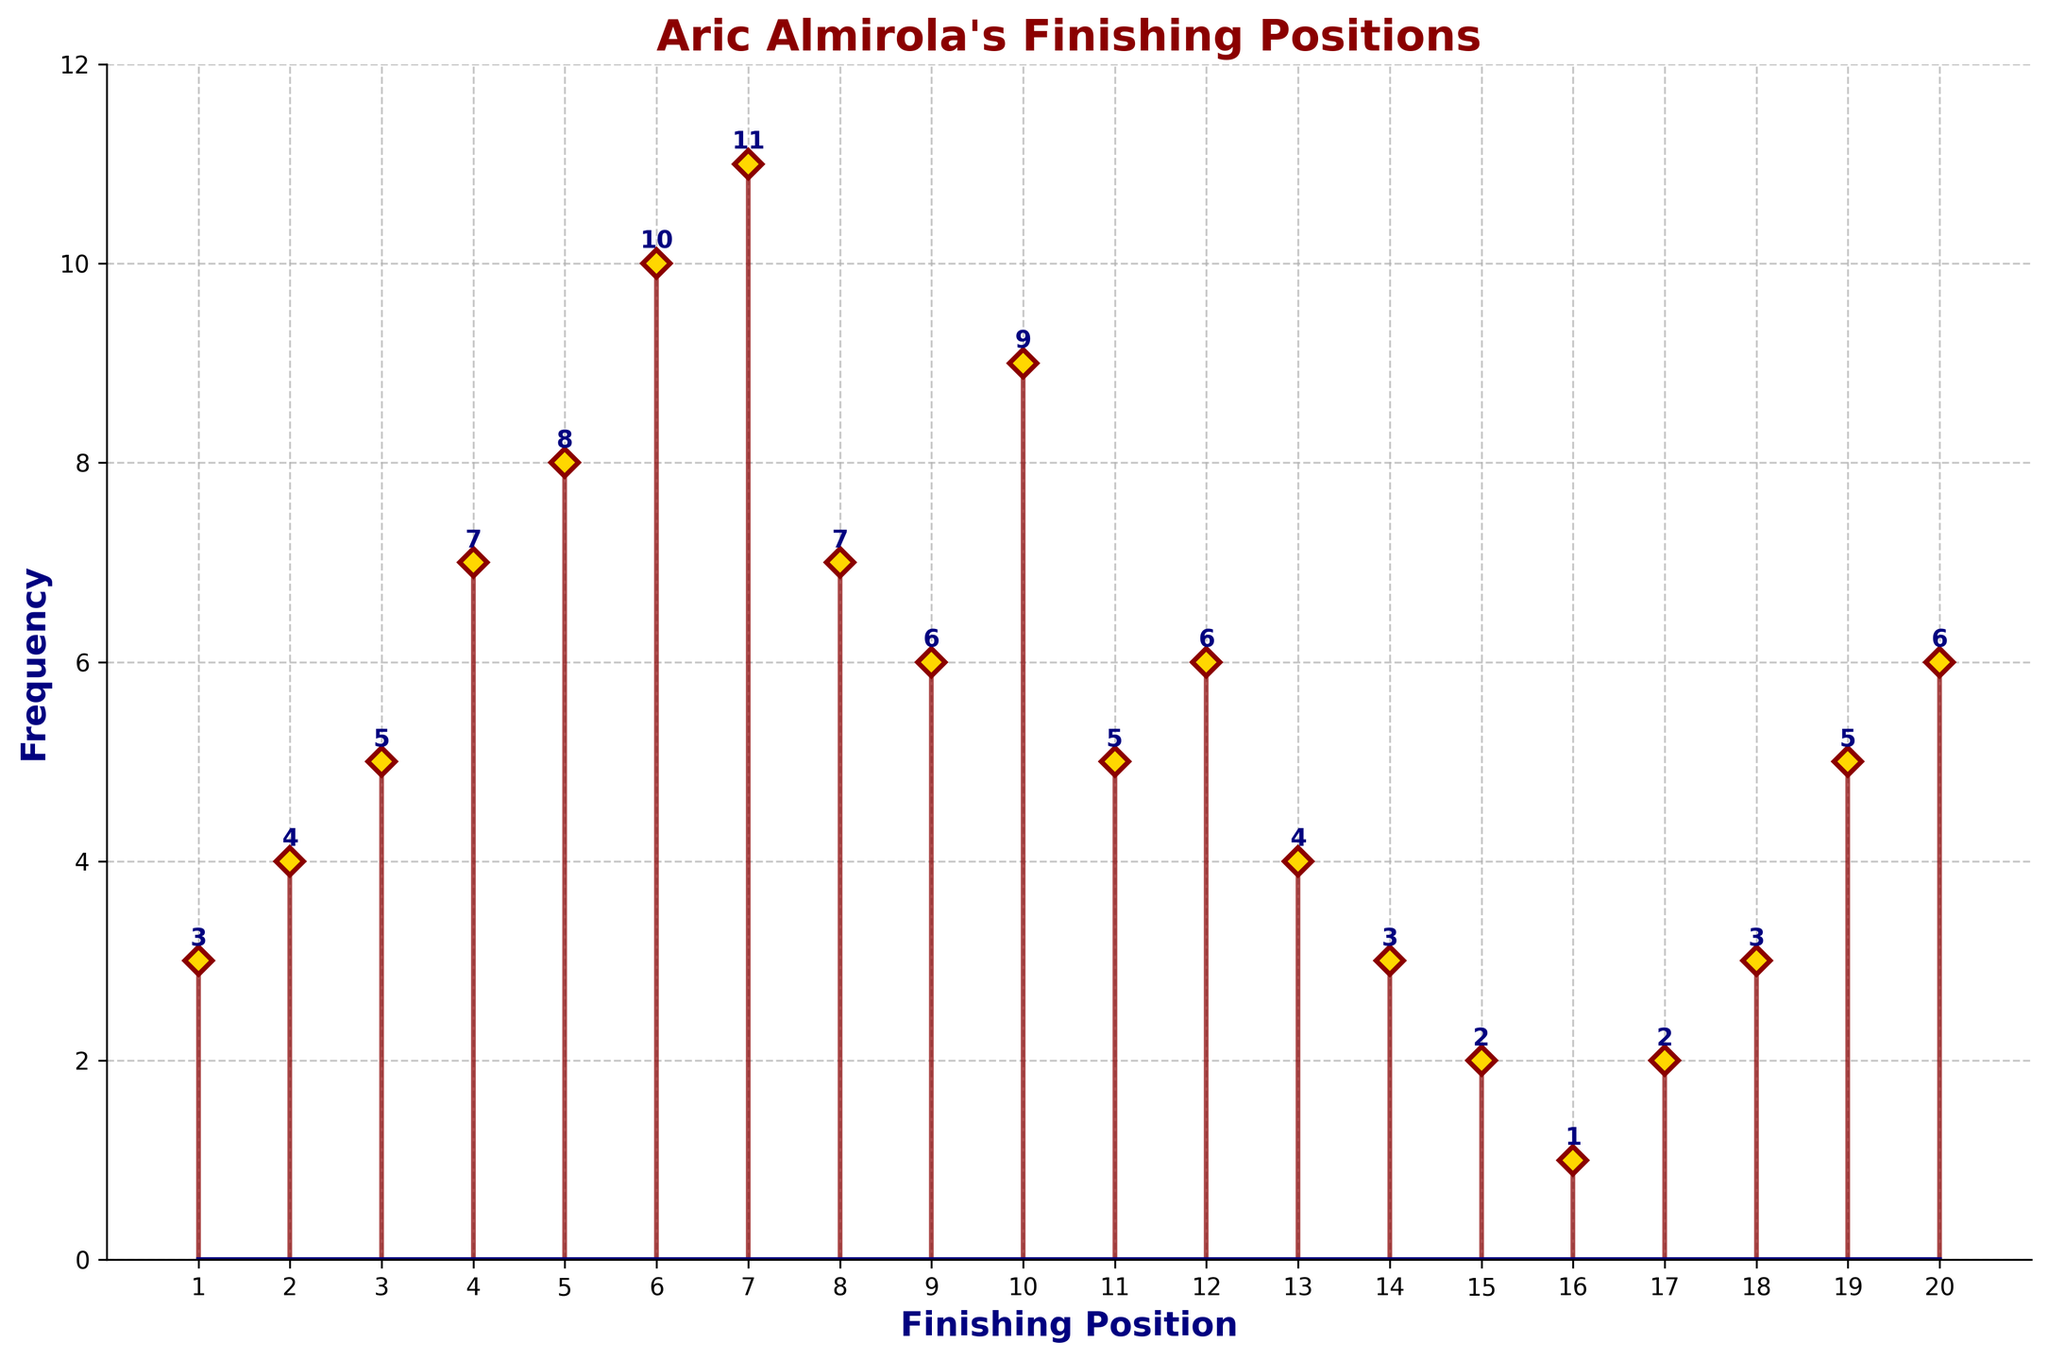what is the title of the stem plot? The title of the stem plot is displayed prominently at the top of the plot in bold dark red font.
Answer: Aric Almirola's Finishing Positions how many times did Aric Almirola finish in 10th place? The stem corresponding to the 10th finishing position has a marker at 9 on the frequency axis.
Answer: 9 times what is the frequency of finishes in the 5th position? The stem for the 5th position points to 8 on the frequency axis, with a text label '8' above it.
Answer: 8 what position did Aric Almirola finish in the least number of times? The stem plot shows positions with frequencies marked on the y-axis. The position with the lowest frequency (1) is observed at the 16th finishing position.
Answer: 16th position what is the total frequency for finishes from 1st to 5th positions? Sum the frequencies of positions 1 to 5: 3 (1st) + 4 (2nd) + 5 (3rd) + 7 (4th) + 8 (5th) = 27.
Answer: 27 which position has the highest frequency of finishes, and what is that frequency? The highest stem on the plot, marked at 11 on the frequency axis, corresponds to the 7th finishing position.
Answer: 7th position, 11 how many positions have a frequency higher than 7? The stems corresponding to the frequencies greater than 7 are: 6th (10), 7th (11), 10th (9), and 8th (7 is not greater than 7). Hence, three positions have frequencies higher than 7.
Answer: 3 positions what is the combined frequency of finishes for positions 6, 7, and 8? Add the frequencies of positions 6, 7, and 8: 10 (6th) + 11 (7th) + 7 (8th) = 28.
Answer: 28 how many different positions has Aric Almirola finished in? Count the number of different positions with non-zero frequencies from the plot, ranging from 1 to 20.
Answer: 20 positions 